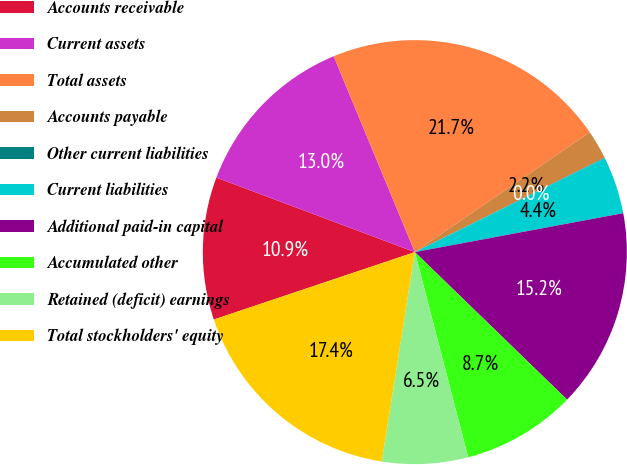Convert chart to OTSL. <chart><loc_0><loc_0><loc_500><loc_500><pie_chart><fcel>Accounts receivable<fcel>Current assets<fcel>Total assets<fcel>Accounts payable<fcel>Other current liabilities<fcel>Current liabilities<fcel>Additional paid-in capital<fcel>Accumulated other<fcel>Retained (deficit) earnings<fcel>Total stockholders' equity<nl><fcel>10.87%<fcel>13.03%<fcel>21.69%<fcel>2.21%<fcel>0.04%<fcel>4.37%<fcel>15.19%<fcel>8.7%<fcel>6.54%<fcel>17.36%<nl></chart> 